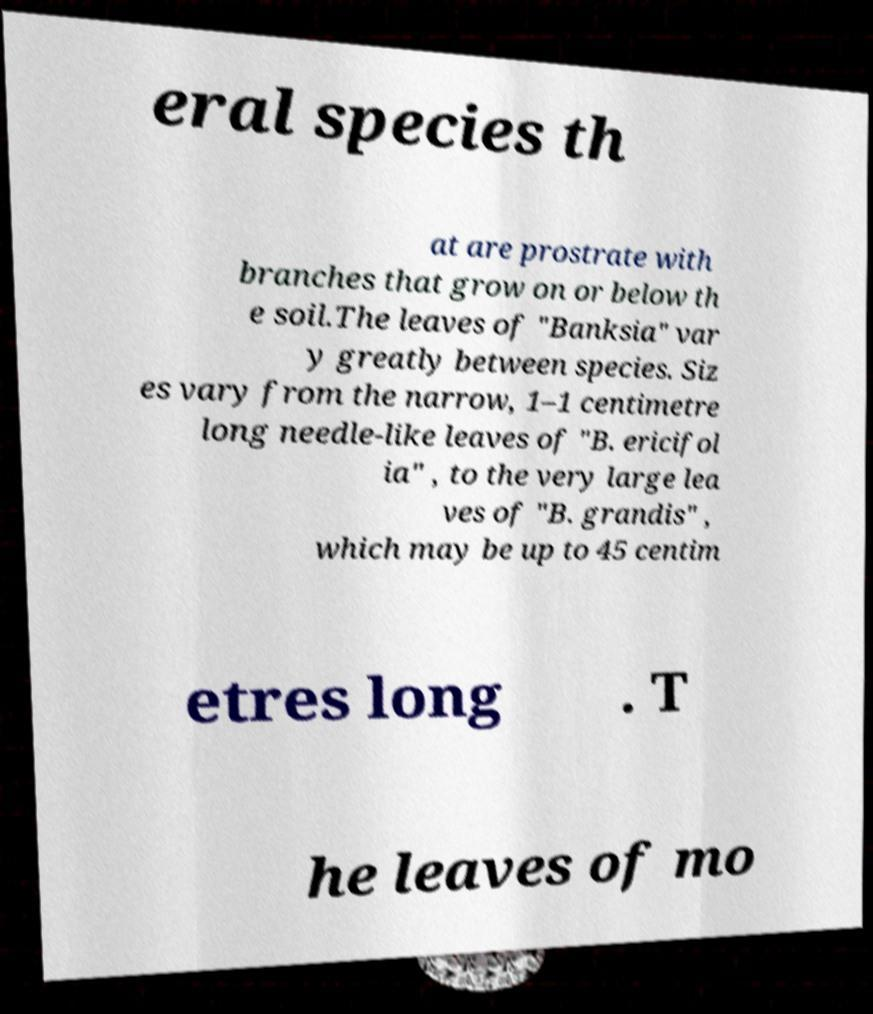What messages or text are displayed in this image? I need them in a readable, typed format. eral species th at are prostrate with branches that grow on or below th e soil.The leaves of "Banksia" var y greatly between species. Siz es vary from the narrow, 1–1 centimetre long needle-like leaves of "B. ericifol ia" , to the very large lea ves of "B. grandis" , which may be up to 45 centim etres long . T he leaves of mo 